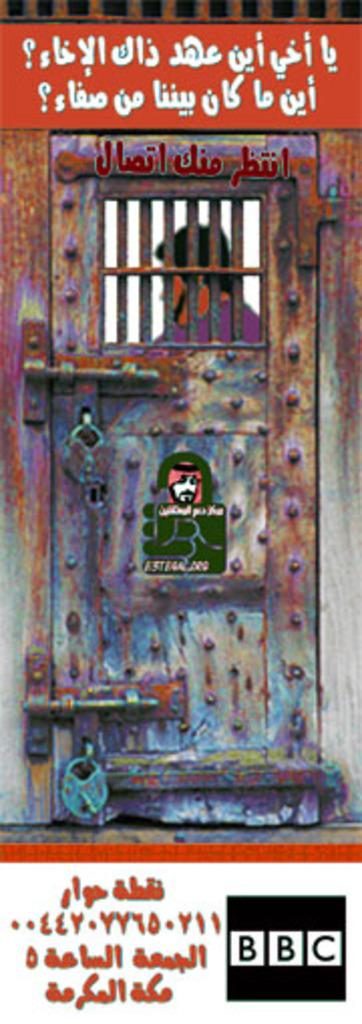<image>
Relay a brief, clear account of the picture shown. A scene from a BBC show has writing in a foreign language on it. 